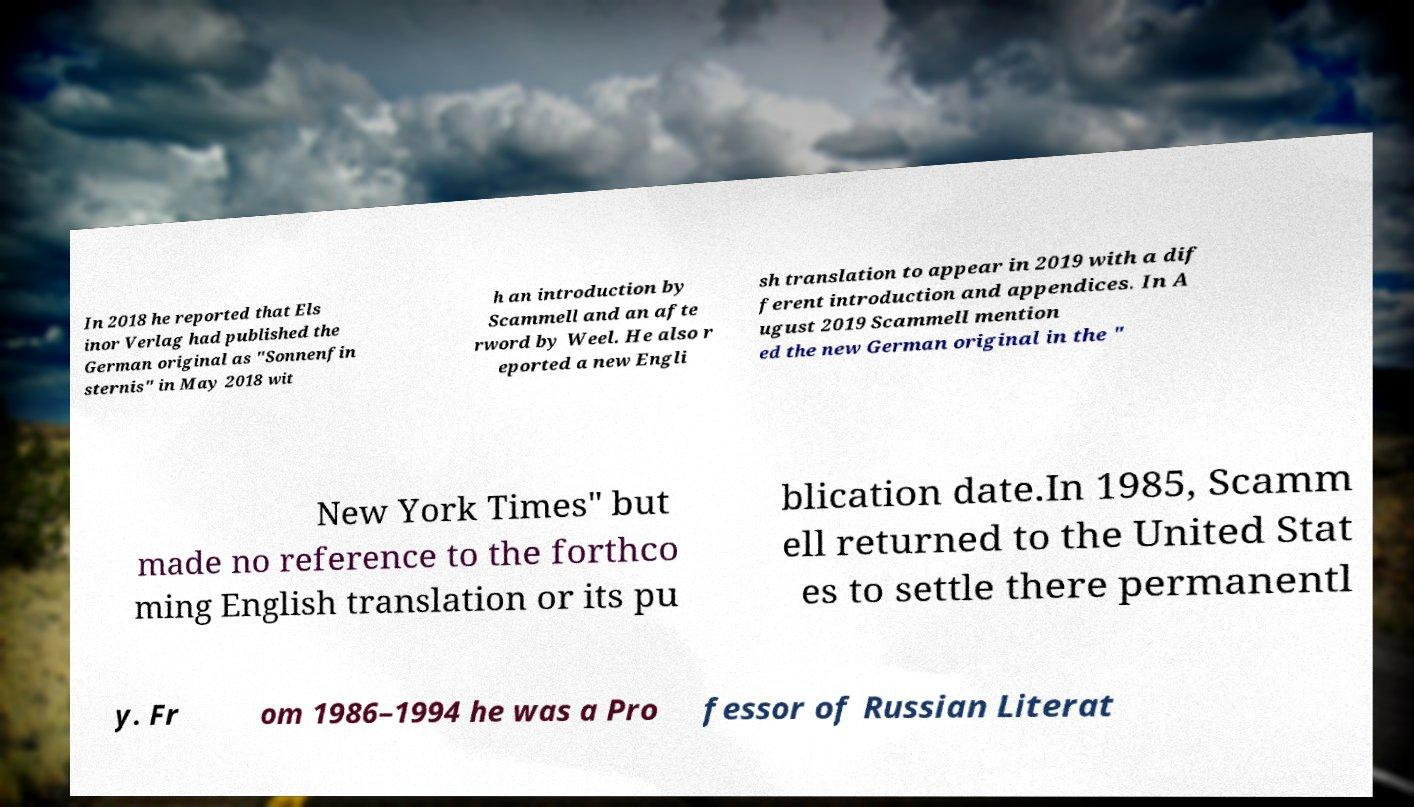Can you accurately transcribe the text from the provided image for me? In 2018 he reported that Els inor Verlag had published the German original as "Sonnenfin sternis" in May 2018 wit h an introduction by Scammell and an afte rword by Weel. He also r eported a new Engli sh translation to appear in 2019 with a dif ferent introduction and appendices. In A ugust 2019 Scammell mention ed the new German original in the " New York Times" but made no reference to the forthco ming English translation or its pu blication date.In 1985, Scamm ell returned to the United Stat es to settle there permanentl y. Fr om 1986–1994 he was a Pro fessor of Russian Literat 